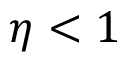Convert formula to latex. <formula><loc_0><loc_0><loc_500><loc_500>\eta < 1</formula> 